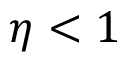Convert formula to latex. <formula><loc_0><loc_0><loc_500><loc_500>\eta < 1</formula> 